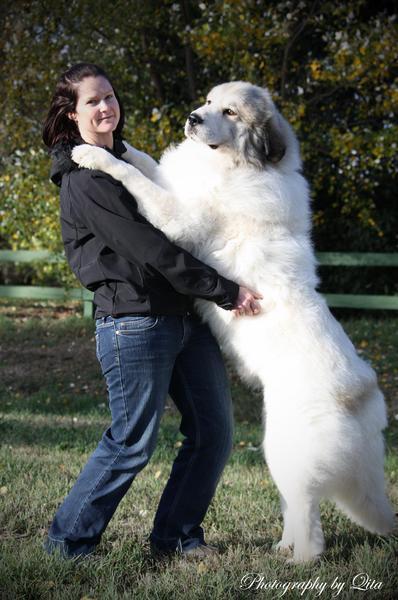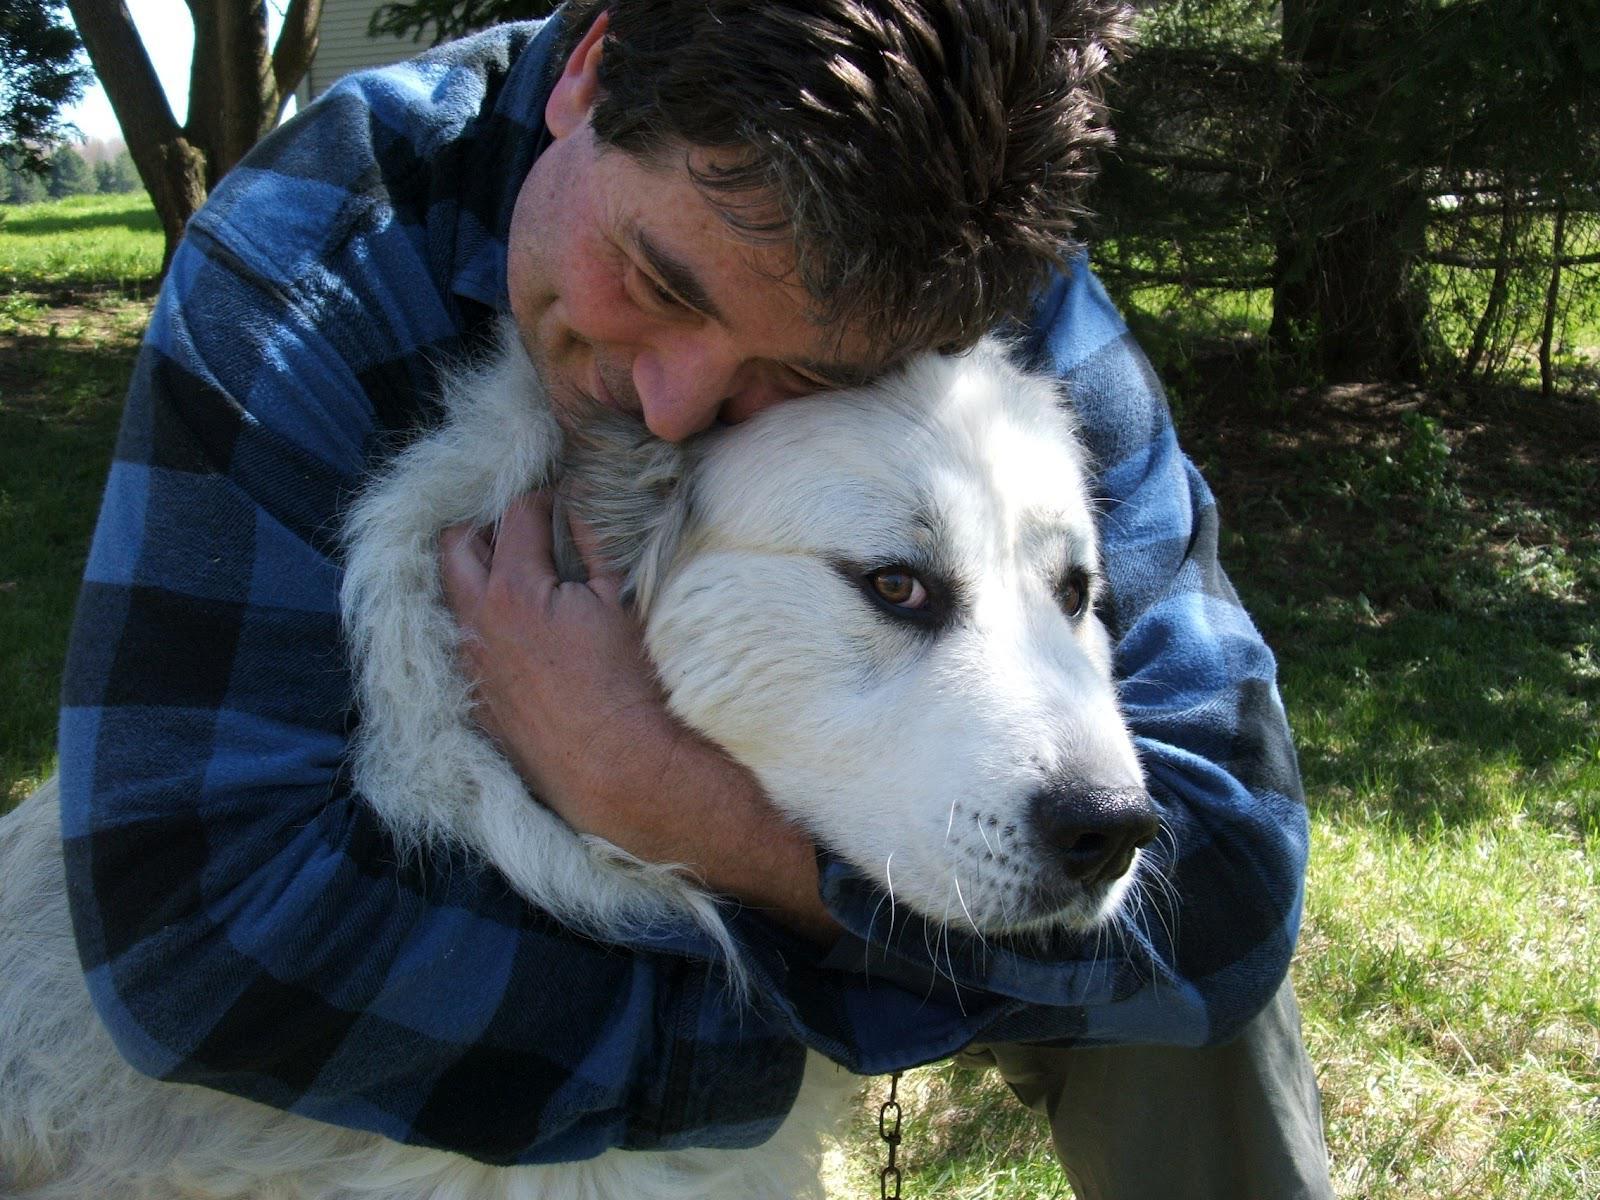The first image is the image on the left, the second image is the image on the right. For the images displayed, is the sentence "At least one of the dogs is with a human." factually correct? Answer yes or no. Yes. 